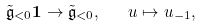<formula> <loc_0><loc_0><loc_500><loc_500>\tilde { \mathfrak g } _ { < 0 } \mathbf 1 \to \tilde { \mathfrak g } _ { < 0 } , \quad u \mapsto u _ { - 1 } ,</formula> 